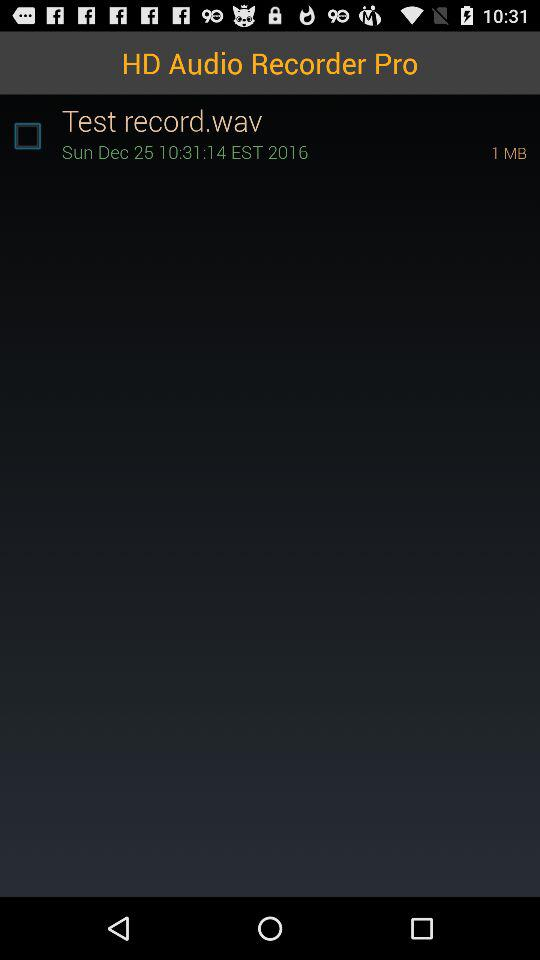What is the date of the "Test record"? The date is Sunday, December 25. 